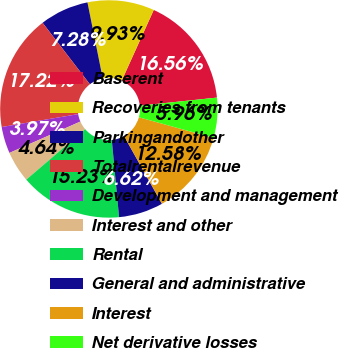Convert chart. <chart><loc_0><loc_0><loc_500><loc_500><pie_chart><fcel>Baserent<fcel>Recoveries from tenants<fcel>Parkingandother<fcel>Totalrentalrevenue<fcel>Development and management<fcel>Interest and other<fcel>Rental<fcel>General and administrative<fcel>Interest<fcel>Net derivative losses<nl><fcel>16.56%<fcel>9.93%<fcel>7.28%<fcel>17.22%<fcel>3.97%<fcel>4.64%<fcel>15.23%<fcel>6.62%<fcel>12.58%<fcel>5.96%<nl></chart> 